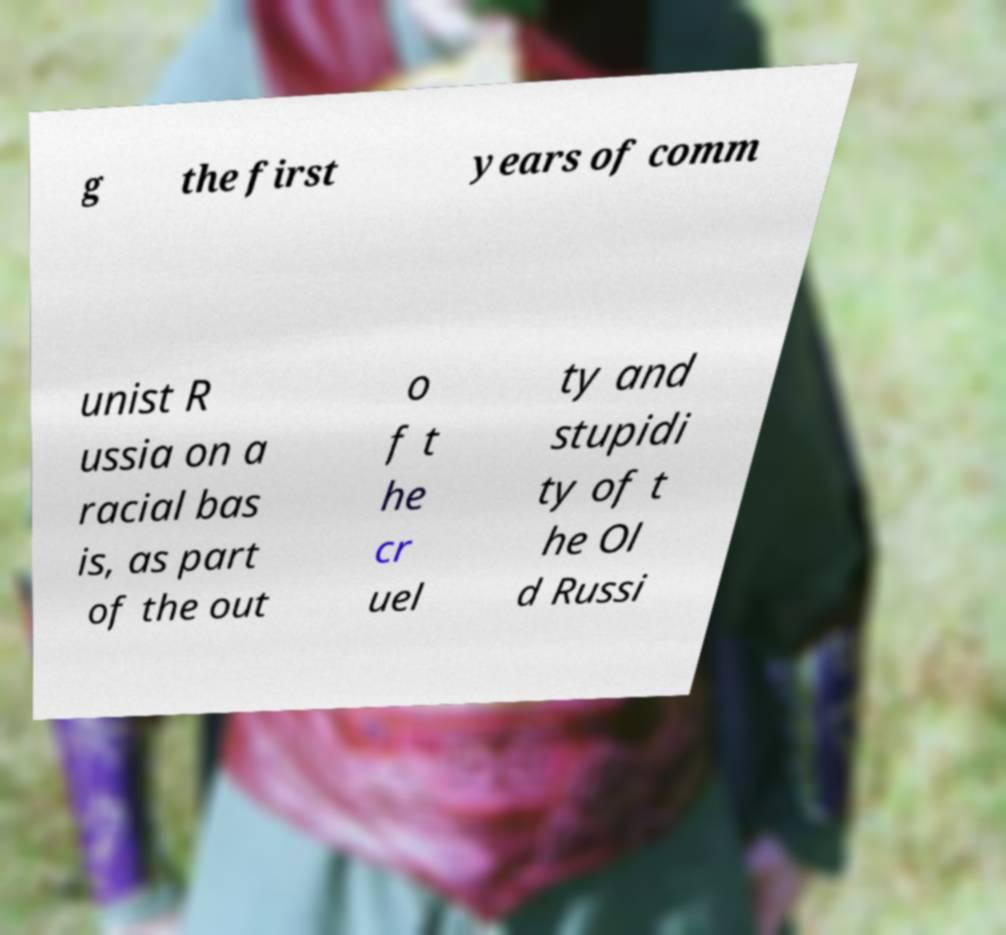There's text embedded in this image that I need extracted. Can you transcribe it verbatim? g the first years of comm unist R ussia on a racial bas is, as part of the out o f t he cr uel ty and stupidi ty of t he Ol d Russi 